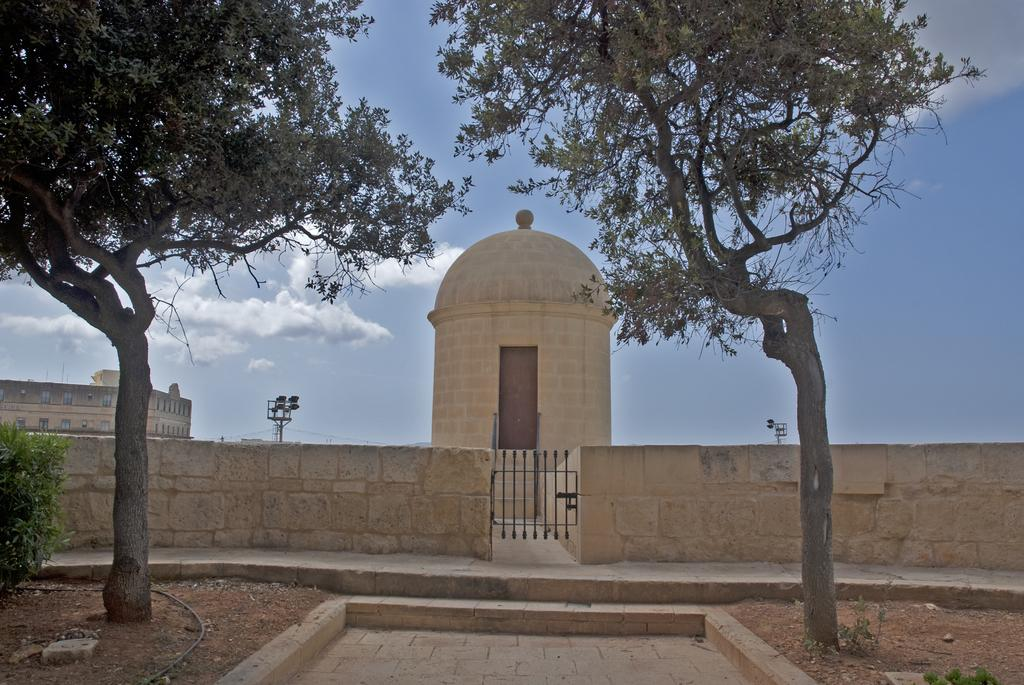What type of natural elements can be seen in the image? There are trees in the image. What type of man-made structures can be seen in the image? There are buildings, poles, a wall, and an iron gate in the image. What type of vegetation is present in the image? There is a plant in the image. What can be seen in the background of the image? Clouds and the sky are visible in the background. What type of waste can be seen in the image? There is no waste present in the image. What type of glass object can be seen in the image? There is no glass object present in the image. 